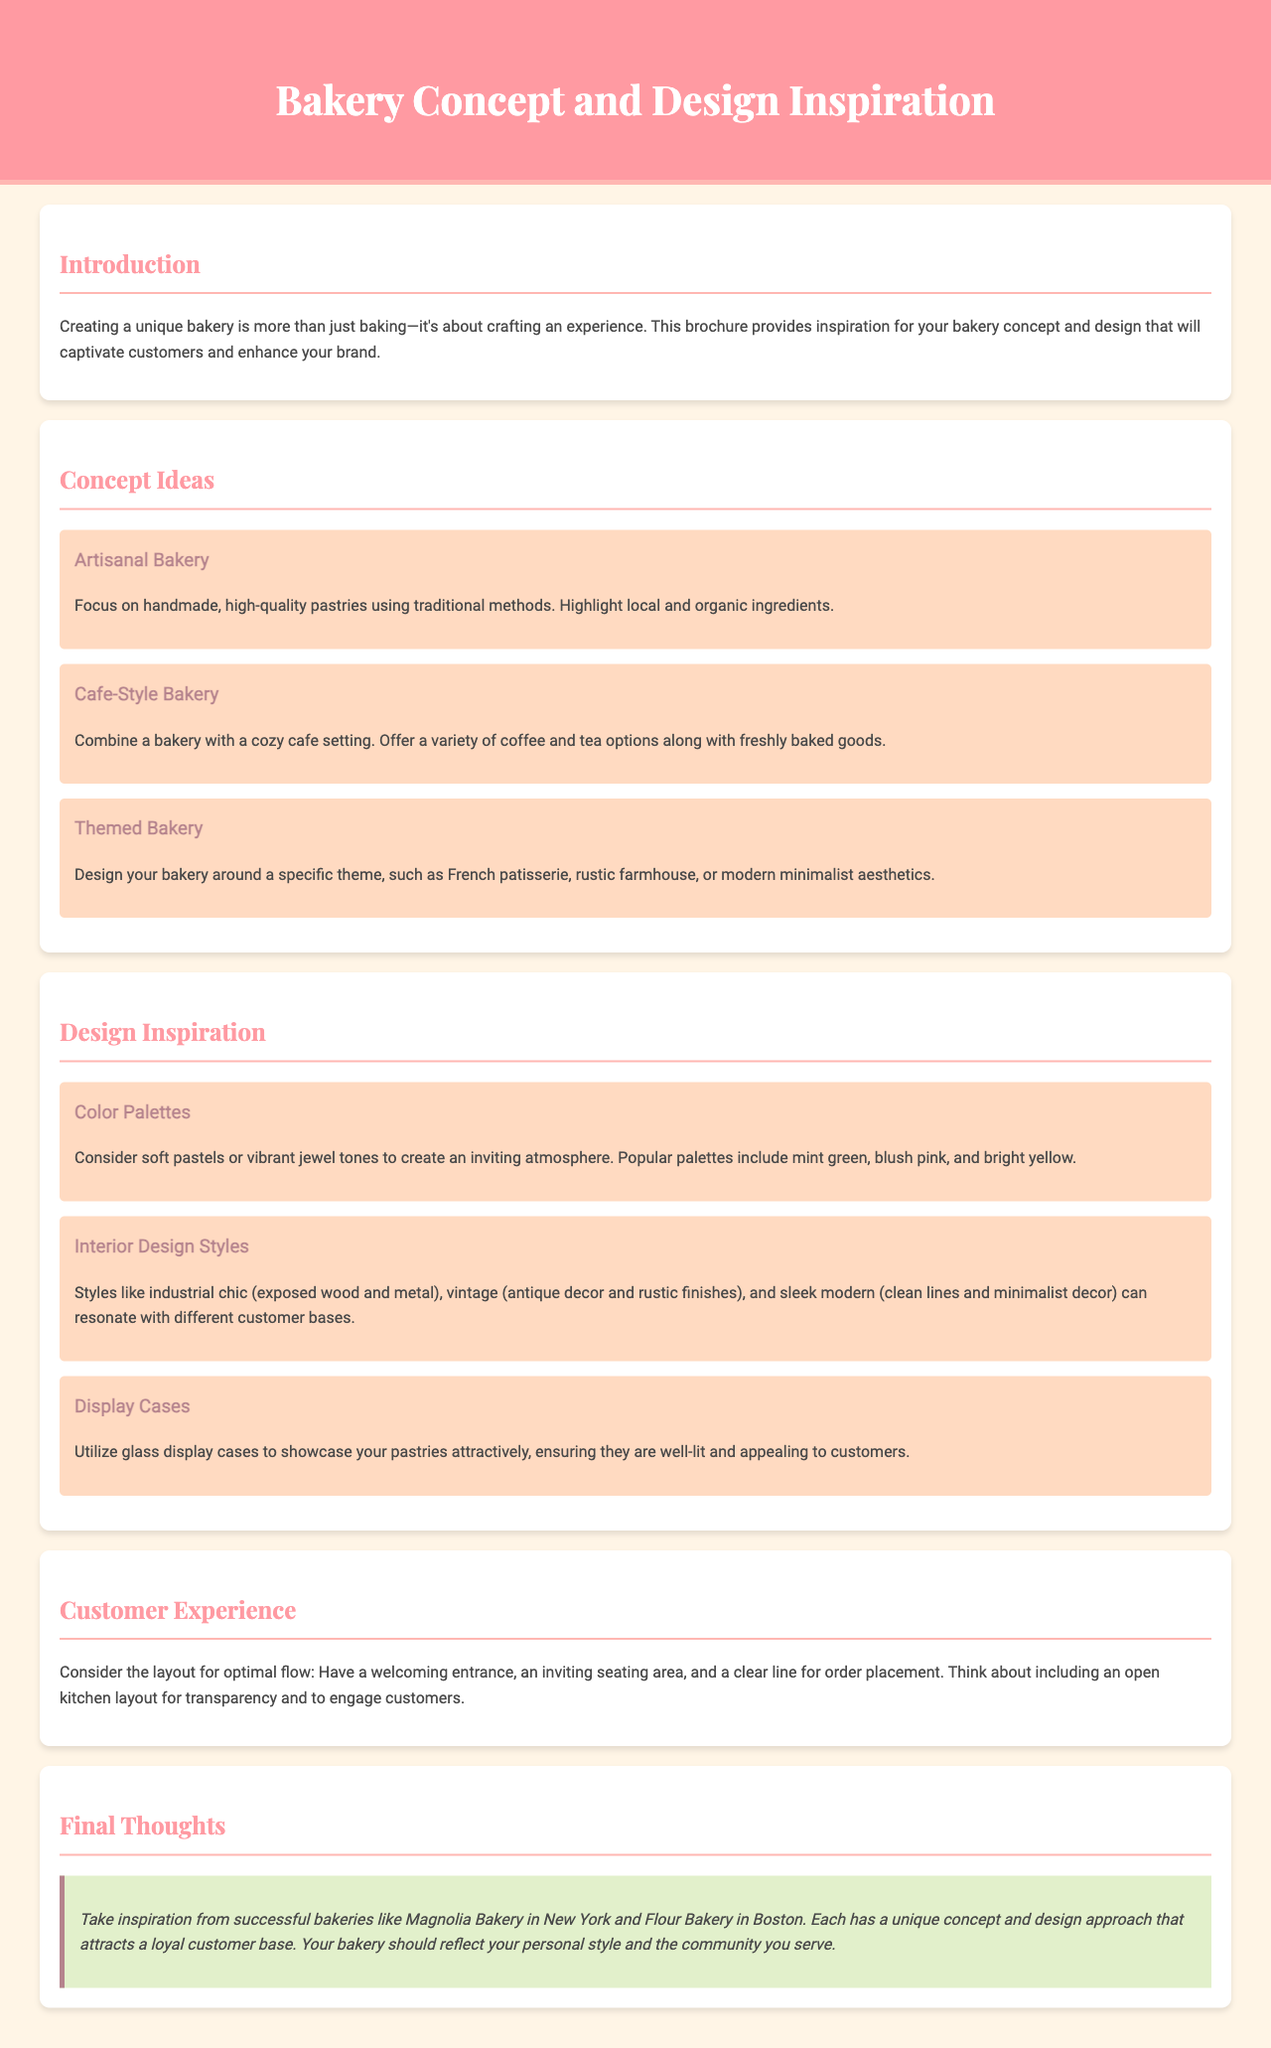what is the title of the document? The title is prominently displayed in the header section of the document.
Answer: Bakery Concept and Design Inspiration how many concept ideas are listed? The document includes a section titled "Concept Ideas" that quantifies the ideas presented.
Answer: Three what is one example of a themed bakery? The themed bakery concept is mentioned in the document as a specific approach to design.
Answer: French patisserie which color palette is suggested for creating an inviting atmosphere? The document recommends certain color palettes that contribute to the atmosphere of the bakery.
Answer: Soft pastels what is one interior design style mentioned? The document lists various interior design styles that can influence the bakery's ambiance.
Answer: Vintage what customer experience layout suggestion is discussed? The document includes a section that highlights important aspects for customer experience layout.
Answer: Welcoming entrance who are two successful bakeries mentioned for inspiration? The document cites successful bakeries as examples for drawing inspiration from their concepts and designs.
Answer: Magnolia Bakery, Flour Bakery what is the purpose of using glass display cases? The document details the functional aspect of display cases in relation to bakery products.
Answer: Showcase pastries attractively 